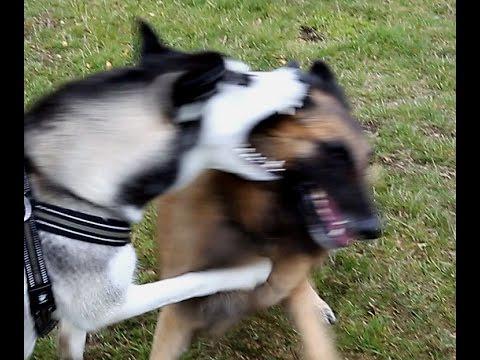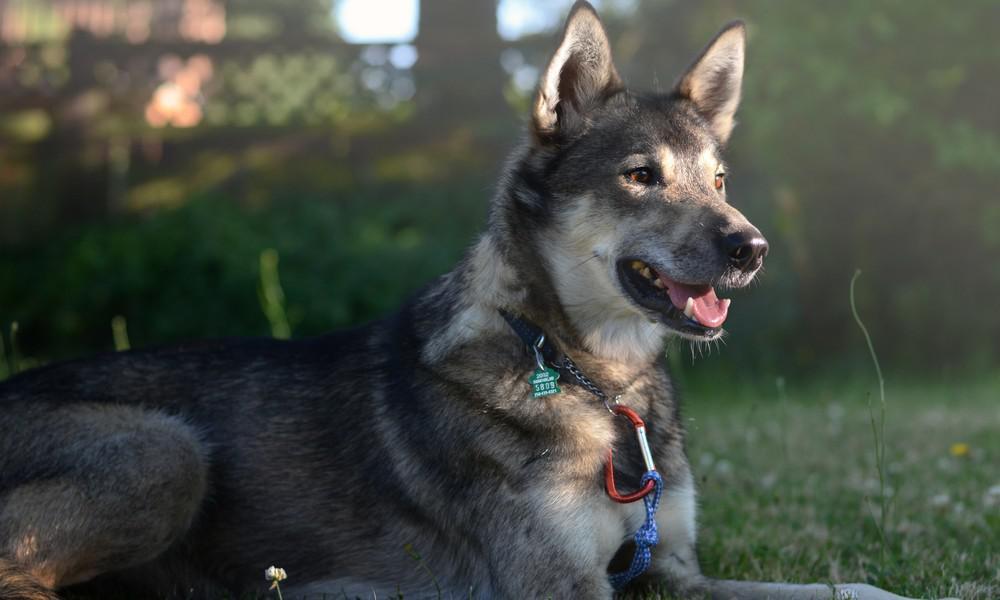The first image is the image on the left, the second image is the image on the right. For the images shown, is this caption "There are at least two dogs in the left image." true? Answer yes or no. Yes. The first image is the image on the left, the second image is the image on the right. Evaluate the accuracy of this statement regarding the images: "There are two dogs together outside in the image on the left.". Is it true? Answer yes or no. Yes. 